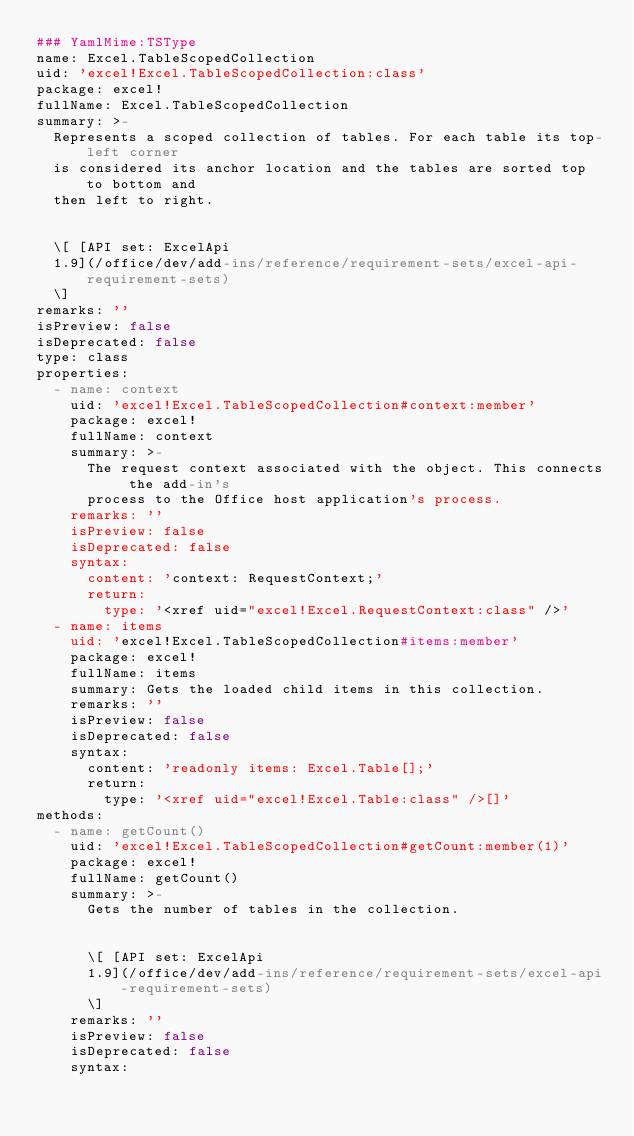<code> <loc_0><loc_0><loc_500><loc_500><_YAML_>### YamlMime:TSType
name: Excel.TableScopedCollection
uid: 'excel!Excel.TableScopedCollection:class'
package: excel!
fullName: Excel.TableScopedCollection
summary: >-
  Represents a scoped collection of tables. For each table its top-left corner
  is considered its anchor location and the tables are sorted top to bottom and
  then left to right.


  \[ [API set: ExcelApi
  1.9](/office/dev/add-ins/reference/requirement-sets/excel-api-requirement-sets)
  \]
remarks: ''
isPreview: false
isDeprecated: false
type: class
properties:
  - name: context
    uid: 'excel!Excel.TableScopedCollection#context:member'
    package: excel!
    fullName: context
    summary: >-
      The request context associated with the object. This connects the add-in's
      process to the Office host application's process.
    remarks: ''
    isPreview: false
    isDeprecated: false
    syntax:
      content: 'context: RequestContext;'
      return:
        type: '<xref uid="excel!Excel.RequestContext:class" />'
  - name: items
    uid: 'excel!Excel.TableScopedCollection#items:member'
    package: excel!
    fullName: items
    summary: Gets the loaded child items in this collection.
    remarks: ''
    isPreview: false
    isDeprecated: false
    syntax:
      content: 'readonly items: Excel.Table[];'
      return:
        type: '<xref uid="excel!Excel.Table:class" />[]'
methods:
  - name: getCount()
    uid: 'excel!Excel.TableScopedCollection#getCount:member(1)'
    package: excel!
    fullName: getCount()
    summary: >-
      Gets the number of tables in the collection.


      \[ [API set: ExcelApi
      1.9](/office/dev/add-ins/reference/requirement-sets/excel-api-requirement-sets)
      \]
    remarks: ''
    isPreview: false
    isDeprecated: false
    syntax:</code> 